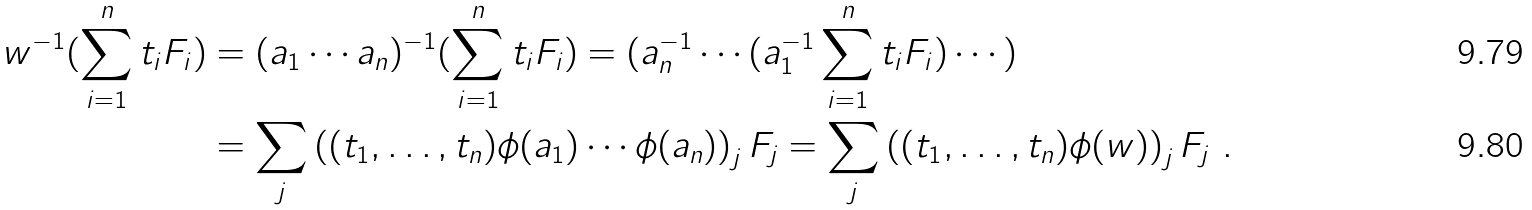Convert formula to latex. <formula><loc_0><loc_0><loc_500><loc_500>w ^ { - 1 } ( \sum _ { i = 1 } ^ { n } t _ { i } F _ { i } ) & = ( a _ { 1 } \cdots a _ { n } ) ^ { - 1 } ( \sum _ { i = 1 } ^ { n } t _ { i } F _ { i } ) = ( a _ { n } ^ { - 1 } \cdots ( a _ { 1 } ^ { - 1 } \sum _ { i = 1 } ^ { n } t _ { i } F _ { i } ) \cdots ) \\ & = \sum _ { j } \left ( ( t _ { 1 } , \dots , t _ { n } ) \phi ( a _ { 1 } ) \cdots \phi ( a _ { n } ) \right ) _ { j } F _ { j } = \sum _ { j } \left ( ( t _ { 1 } , \dots , t _ { n } ) \phi ( w ) \right ) _ { j } F _ { j } \ .</formula> 